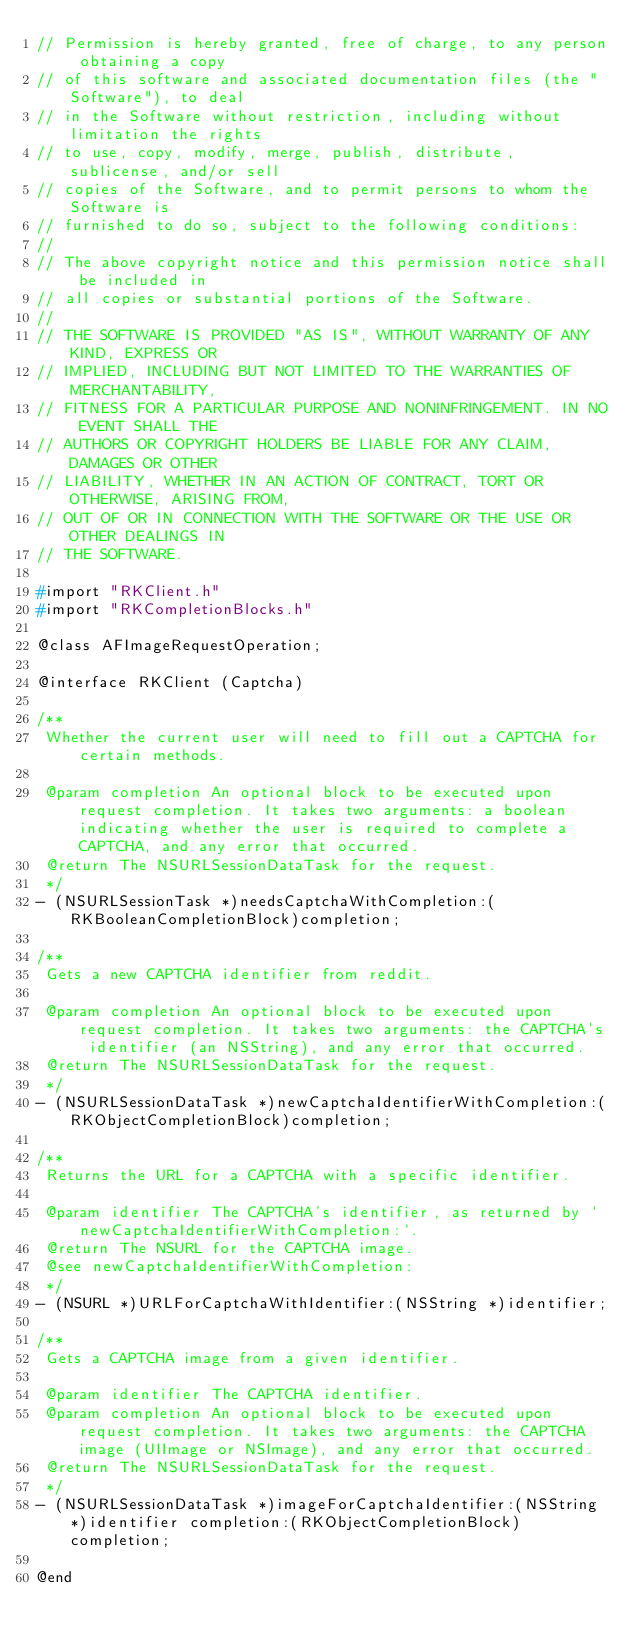<code> <loc_0><loc_0><loc_500><loc_500><_C_>// Permission is hereby granted, free of charge, to any person obtaining a copy
// of this software and associated documentation files (the "Software"), to deal
// in the Software without restriction, including without limitation the rights
// to use, copy, modify, merge, publish, distribute, sublicense, and/or sell
// copies of the Software, and to permit persons to whom the Software is
// furnished to do so, subject to the following conditions:
//
// The above copyright notice and this permission notice shall be included in
// all copies or substantial portions of the Software.
//
// THE SOFTWARE IS PROVIDED "AS IS", WITHOUT WARRANTY OF ANY KIND, EXPRESS OR
// IMPLIED, INCLUDING BUT NOT LIMITED TO THE WARRANTIES OF MERCHANTABILITY,
// FITNESS FOR A PARTICULAR PURPOSE AND NONINFRINGEMENT. IN NO EVENT SHALL THE
// AUTHORS OR COPYRIGHT HOLDERS BE LIABLE FOR ANY CLAIM, DAMAGES OR OTHER
// LIABILITY, WHETHER IN AN ACTION OF CONTRACT, TORT OR OTHERWISE, ARISING FROM,
// OUT OF OR IN CONNECTION WITH THE SOFTWARE OR THE USE OR OTHER DEALINGS IN
// THE SOFTWARE.

#import "RKClient.h"
#import "RKCompletionBlocks.h"

@class AFImageRequestOperation;

@interface RKClient (Captcha)

/**
 Whether the current user will need to fill out a CAPTCHA for certain methods.
 
 @param completion An optional block to be executed upon request completion. It takes two arguments: a boolean indicating whether the user is required to complete a CAPTCHA, and any error that occurred.
 @return The NSURLSessionDataTask for the request.
 */
- (NSURLSessionTask *)needsCaptchaWithCompletion:(RKBooleanCompletionBlock)completion;

/**
 Gets a new CAPTCHA identifier from reddit.
 
 @param completion An optional block to be executed upon request completion. It takes two arguments: the CAPTCHA's identifier (an NSString), and any error that occurred.
 @return The NSURLSessionDataTask for the request.
 */
- (NSURLSessionDataTask *)newCaptchaIdentifierWithCompletion:(RKObjectCompletionBlock)completion;

/**
 Returns the URL for a CAPTCHA with a specific identifier.
 
 @param identifier The CAPTCHA's identifier, as returned by `newCaptchaIdentifierWithCompletion:`.
 @return The NSURL for the CAPTCHA image.
 @see newCaptchaIdentifierWithCompletion:
 */
- (NSURL *)URLForCaptchaWithIdentifier:(NSString *)identifier;

/**
 Gets a CAPTCHA image from a given identifier.
 
 @param identifier The CAPTCHA identifier.
 @param completion An optional block to be executed upon request completion. It takes two arguments: the CAPTCHA image (UIImage or NSImage), and any error that occurred.
 @return The NSURLSessionDataTask for the request.
 */
- (NSURLSessionDataTask *)imageForCaptchaIdentifier:(NSString *)identifier completion:(RKObjectCompletionBlock)completion;

@end
</code> 